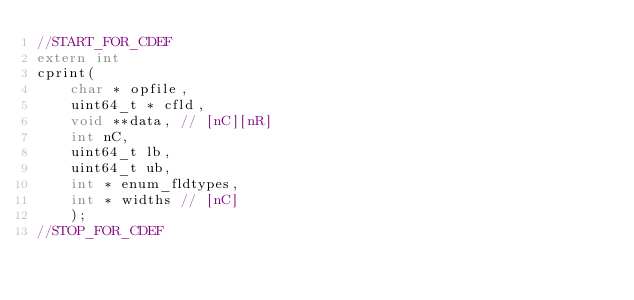<code> <loc_0><loc_0><loc_500><loc_500><_C_>//START_FOR_CDEF
extern int
cprint(
    char * opfile,
    uint64_t * cfld,
    void **data, // [nC][nR] 
    int nC,
    uint64_t lb,
    uint64_t ub,
    int * enum_fldtypes,  
    int * widths // [nC]
    );
//STOP_FOR_CDEF
</code> 